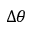<formula> <loc_0><loc_0><loc_500><loc_500>\Delta \theta</formula> 